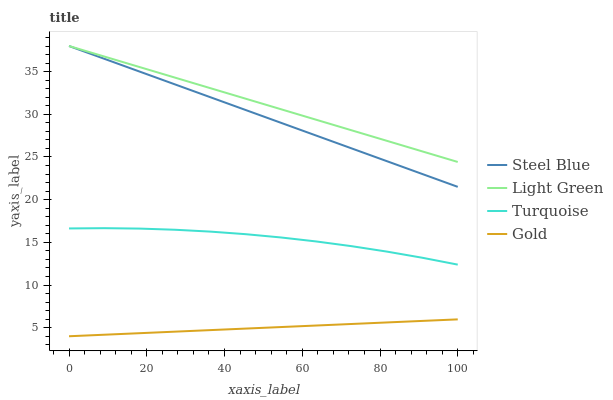Does Gold have the minimum area under the curve?
Answer yes or no. Yes. Does Light Green have the maximum area under the curve?
Answer yes or no. Yes. Does Turquoise have the minimum area under the curve?
Answer yes or no. No. Does Turquoise have the maximum area under the curve?
Answer yes or no. No. Is Light Green the smoothest?
Answer yes or no. Yes. Is Turquoise the roughest?
Answer yes or no. Yes. Is Steel Blue the smoothest?
Answer yes or no. No. Is Steel Blue the roughest?
Answer yes or no. No. Does Gold have the lowest value?
Answer yes or no. Yes. Does Turquoise have the lowest value?
Answer yes or no. No. Does Light Green have the highest value?
Answer yes or no. Yes. Does Turquoise have the highest value?
Answer yes or no. No. Is Gold less than Light Green?
Answer yes or no. Yes. Is Light Green greater than Turquoise?
Answer yes or no. Yes. Does Steel Blue intersect Light Green?
Answer yes or no. Yes. Is Steel Blue less than Light Green?
Answer yes or no. No. Is Steel Blue greater than Light Green?
Answer yes or no. No. Does Gold intersect Light Green?
Answer yes or no. No. 